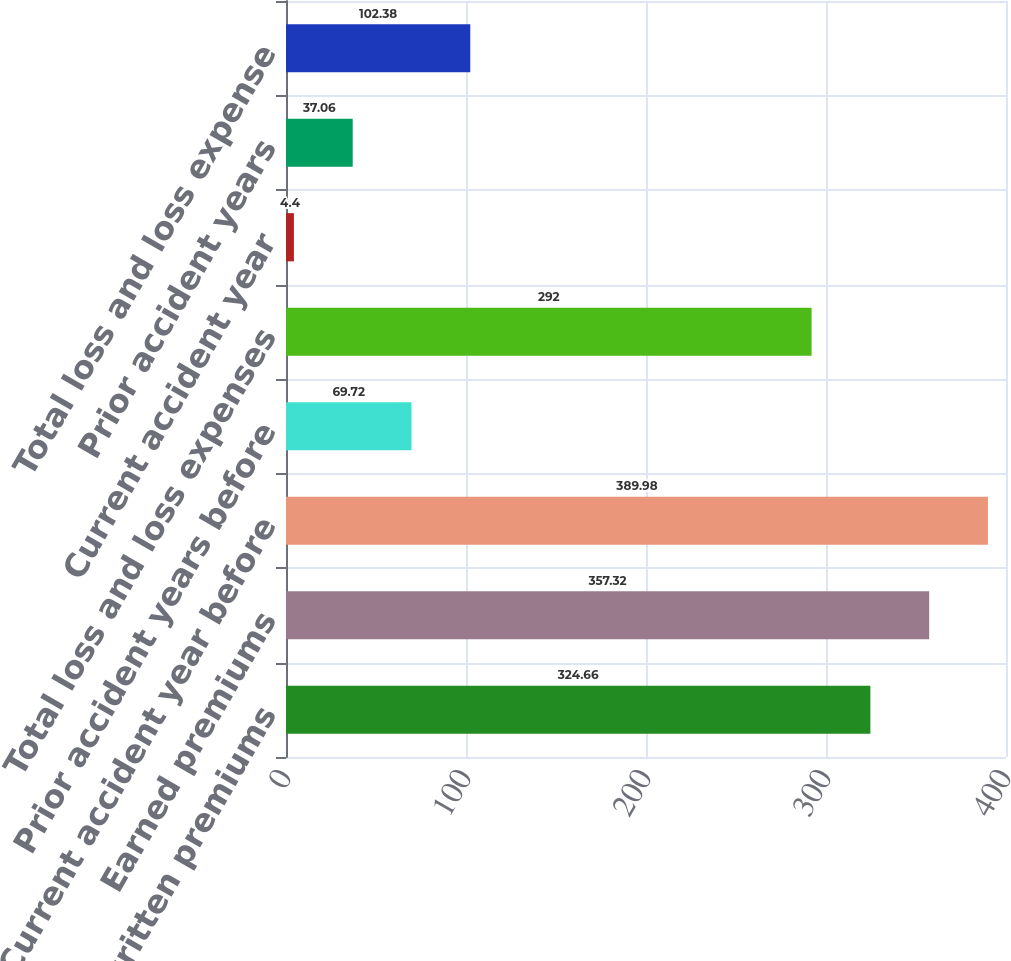Convert chart to OTSL. <chart><loc_0><loc_0><loc_500><loc_500><bar_chart><fcel>Net written premiums<fcel>Earned premiums<fcel>Current accident year before<fcel>Prior accident years before<fcel>Total loss and loss expenses<fcel>Current accident year<fcel>Prior accident years<fcel>Total loss and loss expense<nl><fcel>324.66<fcel>357.32<fcel>389.98<fcel>69.72<fcel>292<fcel>4.4<fcel>37.06<fcel>102.38<nl></chart> 